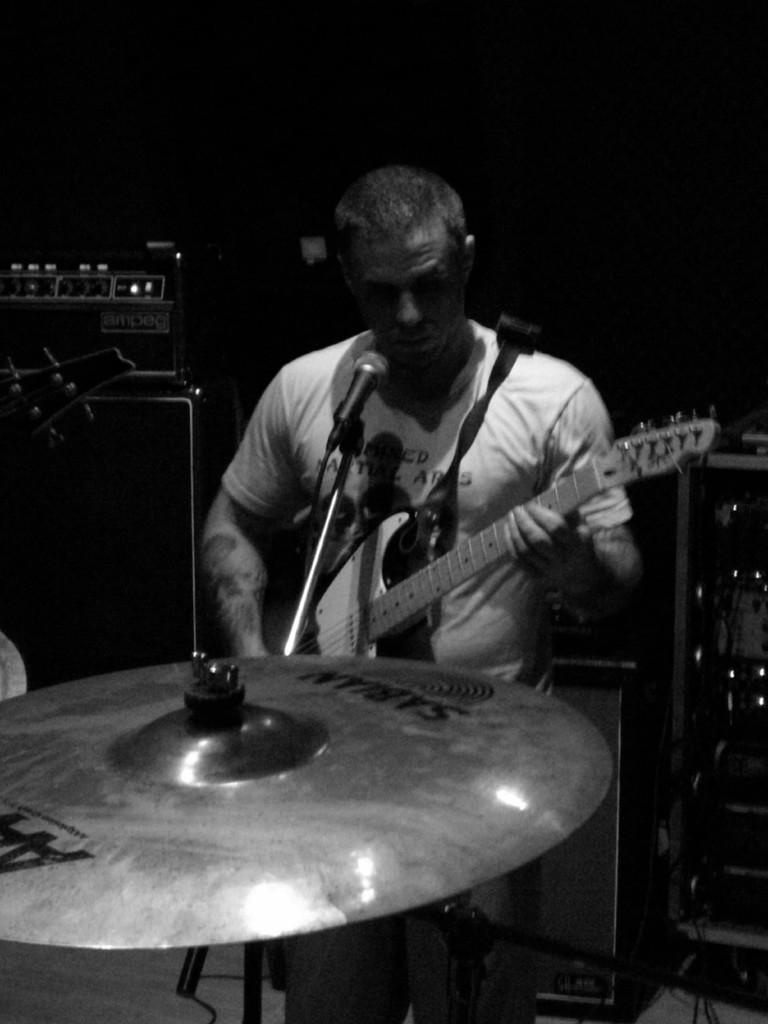What is the man in the image doing? The man is playing a guitar in the image. What else can be seen in the image related to the man's activity? There is a band at the bottom of the image, which suggests that the man is part of a musical performance. What can be seen in the background of the image? There is a speaker in the background of the image. What equipment is present for vocal amplification in the image? There is a microphone on a stand in the image. What type of pen is the maid using to write a note in the image? There is no pen or maid present in the image; it features a man playing a guitar and a band. 